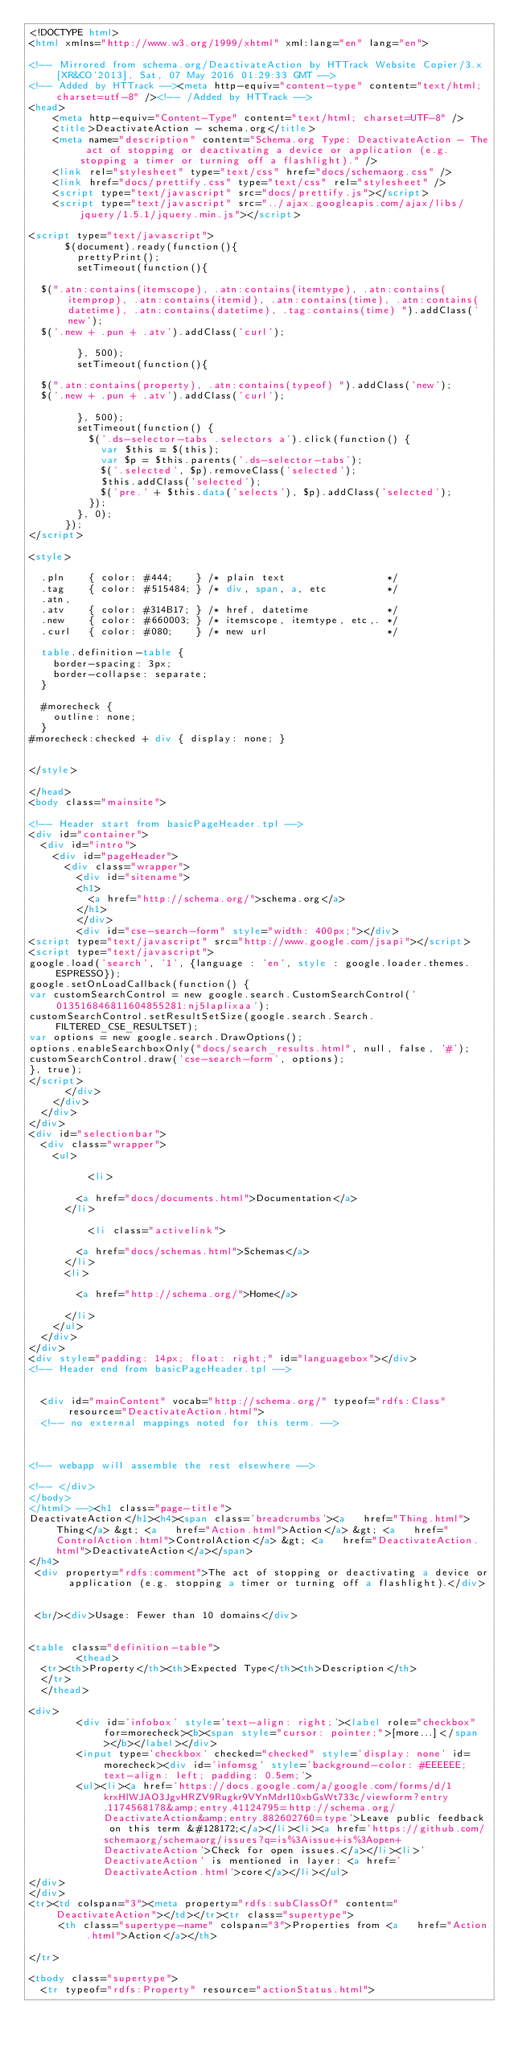<code> <loc_0><loc_0><loc_500><loc_500><_HTML_><!DOCTYPE html>
<html xmlns="http://www.w3.org/1999/xhtml" xml:lang="en" lang="en">

<!-- Mirrored from schema.org/DeactivateAction by HTTrack Website Copier/3.x [XR&CO'2013], Sat, 07 May 2016 01:29:33 GMT -->
<!-- Added by HTTrack --><meta http-equiv="content-type" content="text/html;charset=utf-8" /><!-- /Added by HTTrack -->
<head>
    <meta http-equiv="Content-Type" content="text/html; charset=UTF-8" />
    <title>DeactivateAction - schema.org</title>
    <meta name="description" content="Schema.org Type: DeactivateAction - The act of stopping or deactivating a device or application (e.g. stopping a timer or turning off a flashlight)." />
    <link rel="stylesheet" type="text/css" href="docs/schemaorg.css" />
    <link href="docs/prettify.css" type="text/css" rel="stylesheet" />
    <script type="text/javascript" src="docs/prettify.js"></script>
    <script type="text/javascript" src="../ajax.googleapis.com/ajax/libs/jquery/1.5.1/jquery.min.js"></script>

<script type="text/javascript">
      $(document).ready(function(){
        prettyPrint();
        setTimeout(function(){

  $(".atn:contains(itemscope), .atn:contains(itemtype), .atn:contains(itemprop), .atn:contains(itemid), .atn:contains(time), .atn:contains(datetime), .atn:contains(datetime), .tag:contains(time) ").addClass('new');
  $('.new + .pun + .atv').addClass('curl');

        }, 500);
        setTimeout(function(){

  $(".atn:contains(property), .atn:contains(typeof) ").addClass('new');
  $('.new + .pun + .atv').addClass('curl');

        }, 500);
        setTimeout(function() {
          $('.ds-selector-tabs .selectors a').click(function() {
            var $this = $(this);
            var $p = $this.parents('.ds-selector-tabs');
            $('.selected', $p).removeClass('selected');
            $this.addClass('selected');
            $('pre.' + $this.data('selects'), $p).addClass('selected');
          });
        }, 0);
      });
</script>

<style>

  .pln    { color: #444;    } /* plain text                 */
  .tag    { color: #515484; } /* div, span, a, etc          */
  .atn,
  .atv    { color: #314B17; } /* href, datetime             */
  .new    { color: #660003; } /* itemscope, itemtype, etc,. */
  .curl   { color: #080;    } /* new url                    */

  table.definition-table {
    border-spacing: 3px;
    border-collapse: separate;
  }
  
  #morecheck {
	  outline: none;
  }
#morecheck:checked + div { display: none; }
  

</style>

</head>
<body class="mainsite">

<!-- Header start from basicPageHeader.tpl -->
<div id="container">
	<div id="intro">
		<div id="pageHeader">
			<div class="wrapper">
				<div id="sitename">
				<h1>
					<a href="http://schema.org/">schema.org</a>
				</h1>
				</div>
				<div id="cse-search-form" style="width: 400px;"></div>
<script type="text/javascript" src="http://www.google.com/jsapi"></script> 
<script type="text/javascript">
google.load('search', '1', {language : 'en', style : google.loader.themes.ESPRESSO});
google.setOnLoadCallback(function() {
var customSearchControl = new google.search.CustomSearchControl('013516846811604855281:nj5laplixaa');
customSearchControl.setResultSetSize(google.search.Search.FILTERED_CSE_RESULTSET);
var options = new google.search.DrawOptions();
options.enableSearchboxOnly("docs/search_results.html", null, false, '#');
customSearchControl.draw('cse-search-form', options);
}, true);
</script>
			</div>
		</div>
	</div>
</div>
<div id="selectionbar">
	<div class="wrapper">
		<ul>
	        
	        <li>
	        
				<a href="docs/documents.html">Documentation</a>
			</li>
	        
	        <li class="activelink">
	        
				<a href="docs/schemas.html">Schemas</a>
			</li>
			<li>
	        
				<a href="http://schema.org/">Home</a>
	        
			</li>
		</ul>
	</div>
</div>
<div style="padding: 14px; float: right;" id="languagebox"></div>
<!-- Header end from basicPageHeader.tpl -->


  <div id="mainContent" vocab="http://schema.org/" typeof="rdfs:Class" resource="DeactivateAction.html">
  <!-- no external mappings noted for this term. -->



<!-- webapp will assemble the rest elsewhere -->

<!-- </div>
</body>
</html> --><h1 class="page-title">
DeactivateAction</h1><h4><span class='breadcrumbs'><a   href="Thing.html">Thing</a> &gt; <a   href="Action.html">Action</a> &gt; <a   href="ControlAction.html">ControlAction</a> &gt; <a   href="DeactivateAction.html">DeactivateAction</a></span>
</h4>
 <div property="rdfs:comment">The act of stopping or deactivating a device or application (e.g. stopping a timer or turning off a flashlight).</div>


 <br/><div>Usage: Fewer than 10 domains</div>


<table class="definition-table">
        <thead>
  <tr><th>Property</th><th>Expected Type</th><th>Description</th>               
  </tr>
  </thead>

<div>
        <div id='infobox' style='text-align: right;'><label role="checkbox" for=morecheck><b><span style="cursor: pointer;">[more...]</span></b></label></div>
        <input type='checkbox' checked="checked" style='display: none' id=morecheck><div id='infomsg' style='background-color: #EEEEEE; text-align: left; padding: 0.5em;'>
        <ul><li><a href='https://docs.google.com/a/google.com/forms/d/1krxHlWJAO3JgvHRZV9Rugkr9VYnMdrI10xbGsWt733c/viewform?entry.1174568178&amp;entry.41124795=http://schema.org/DeactivateAction&amp;entry.882602760=type'>Leave public feedback on this term &#128172;</a></li><li><a href='https://github.com/schemaorg/schemaorg/issues?q=is%3Aissue+is%3Aopen+DeactivateAction'>Check for open issues.</a></li><li>'DeactivateAction' is mentioned in layer: <a href='DeactivateAction.html'>core</a></li></ul>
</div>
</div>
<tr><td colspan="3"><meta property="rdfs:subClassOf" content="DeactivateAction"></td></tr><tr class="supertype">
     <th class="supertype-name" colspan="3">Properties from <a   href="Action.html">Action</a></th>
  
</tr>

<tbody class="supertype">
  <tr typeof="rdfs:Property" resource="actionStatus.html">
    </code> 